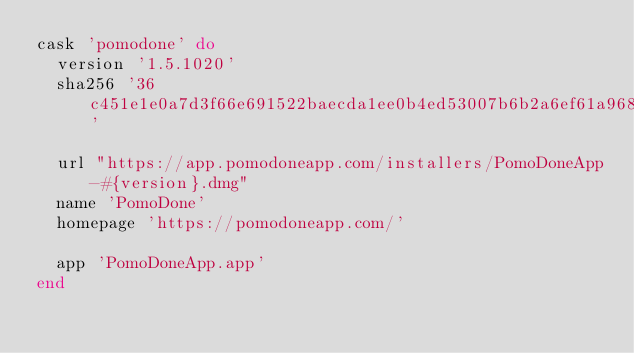<code> <loc_0><loc_0><loc_500><loc_500><_Ruby_>cask 'pomodone' do
  version '1.5.1020'
  sha256 '36c451e1e0a7d3f66e691522baecda1ee0b4ed53007b6b2a6ef61a968d2fa55d'

  url "https://app.pomodoneapp.com/installers/PomoDoneApp-#{version}.dmg"
  name 'PomoDone'
  homepage 'https://pomodoneapp.com/'

  app 'PomoDoneApp.app'
end
</code> 